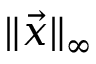<formula> <loc_0><loc_0><loc_500><loc_500>\| { \vec { x } } \| _ { \infty }</formula> 